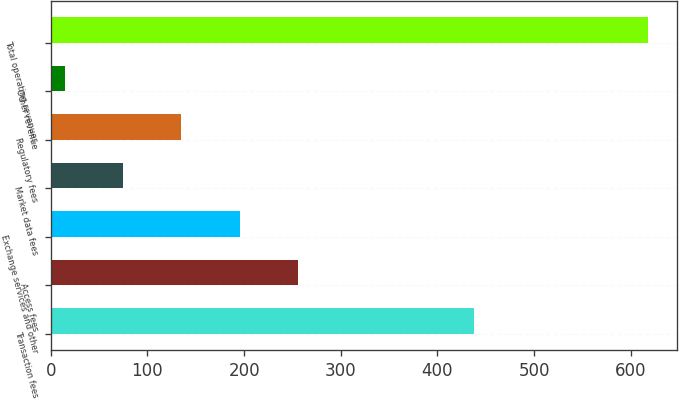Convert chart. <chart><loc_0><loc_0><loc_500><loc_500><bar_chart><fcel>Transaction fees<fcel>Access fees<fcel>Exchange services and other<fcel>Market data fees<fcel>Regulatory fees<fcel>Other revenue<fcel>Total operating revenues<nl><fcel>437.8<fcel>255.64<fcel>195.38<fcel>74.86<fcel>135.12<fcel>14.6<fcel>617.2<nl></chart> 